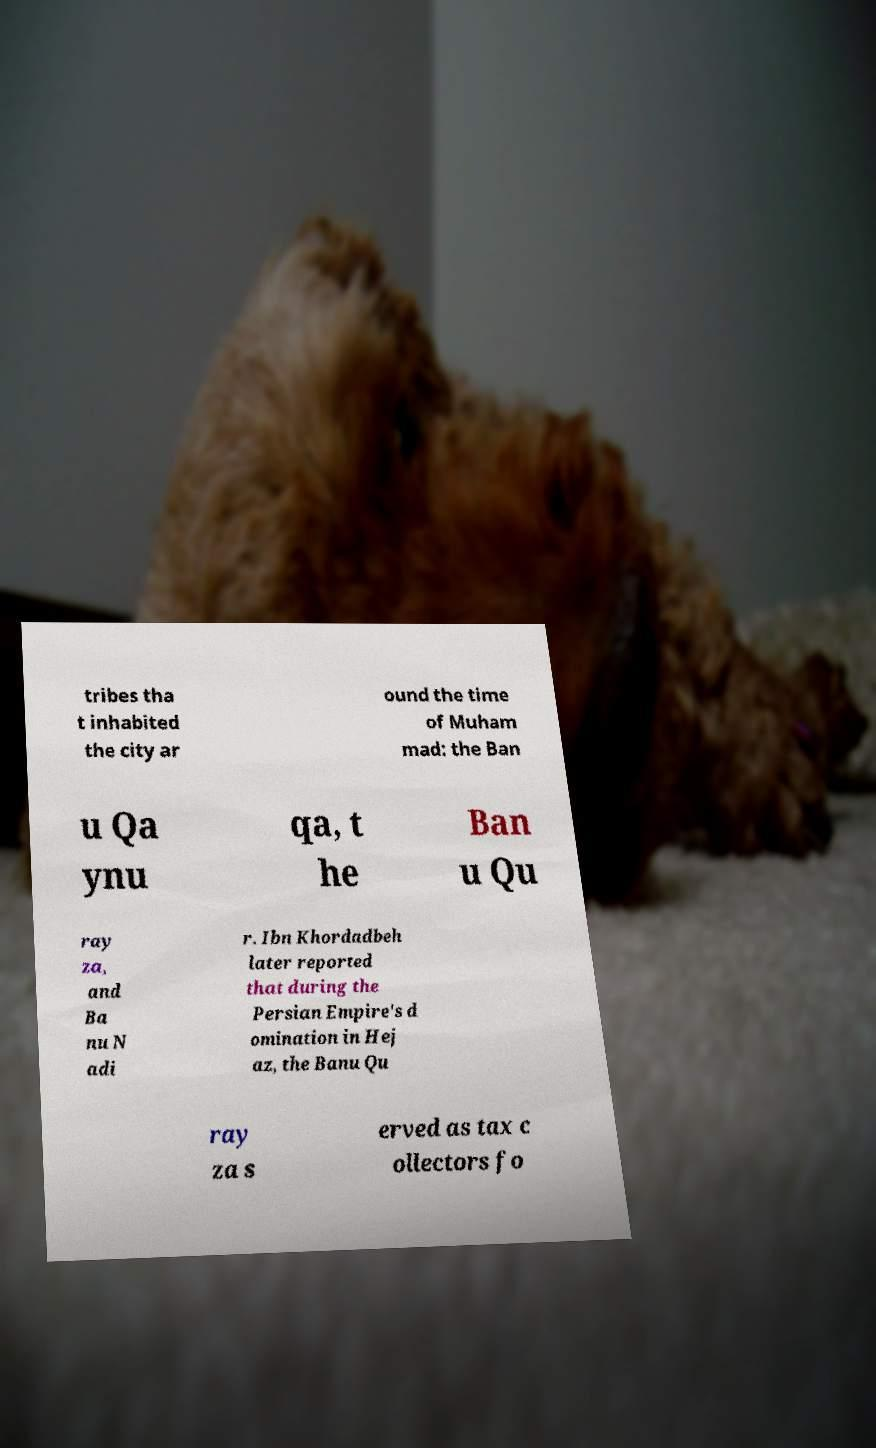Can you accurately transcribe the text from the provided image for me? tribes tha t inhabited the city ar ound the time of Muham mad: the Ban u Qa ynu qa, t he Ban u Qu ray za, and Ba nu N adi r. Ibn Khordadbeh later reported that during the Persian Empire's d omination in Hej az, the Banu Qu ray za s erved as tax c ollectors fo 